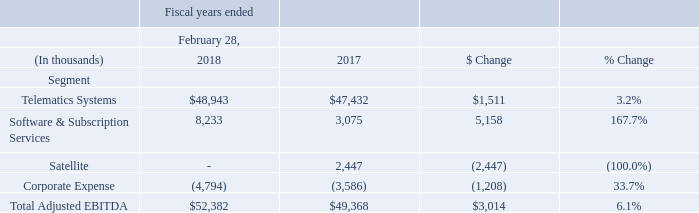Profitability Measures
Net income:
The net income in the fiscal year ended February 28, 2018 was $16.6 million as compared to a net loss of $7.9 million in the same period last year. The increase is primarily the result of the $28.3 million non-operating gain from the legal settlement with a former supplier of LoJack, which was recognized during fiscal 2018. This gain was partially offset by higher tax expense in fiscal 2018 due to U.S. and foreign taxes on the $28.3 million legal settlement gain as well as the revaluation of our net deferred income tax assets that occurred in the fourth quarter of fiscal 2018 as we adopted the provisions of the Tax Cuts and Jobs Act which was enacted on December 22, 2017.
Adjusted EBITDA:
Adjusted EBITDA for Telematics Systems in the fiscal year ended February 28, 2018 increased $1.5 million compared to the same period last year due to higher MRM products revenue. Adjusted EBITDA for Software and Subscription Services increased $5.2 million compared to the same period last year due primarily to lower selling and marketing expenses and lower general and administrative expenses.
See Note 20 for a reconciliation of Adjusted EBITDA by reportable segments and a reconciliation to GAAP-basis net income (loss).
What was the main reason for the increase in net income in the fiscal year ended February 28, 2018? The increase is primarily the result of the $28.3 million non-operating gain from the legal settlement with a former supplier of lojack, which was recognized during fiscal 2018. What was the Adjusted EBITDA for Telematics Systems in 2018?
Answer scale should be: thousand. 48,943. What was the Adjusted EBITDA for Telematics Systems in 2017?
Answer scale should be: thousand. 47,432. What was the total Adjusted EBITDA for Telematics Systems and Software & Subscription Services in 2018?
Answer scale should be: thousand. (48,943+8,233)
Answer: 57176. What was the total Adjusted EBITDA for Telematics Systems and Software & Subscription Services in 2017?
Answer scale should be: thousand. (47,432+3,075)
Answer: 50507. What was the average corporate expense for both years, 2017 and 2018?
Answer scale should be: thousand. (-4,794-3,586)/(2018-2017+1)
Answer: -4190. 